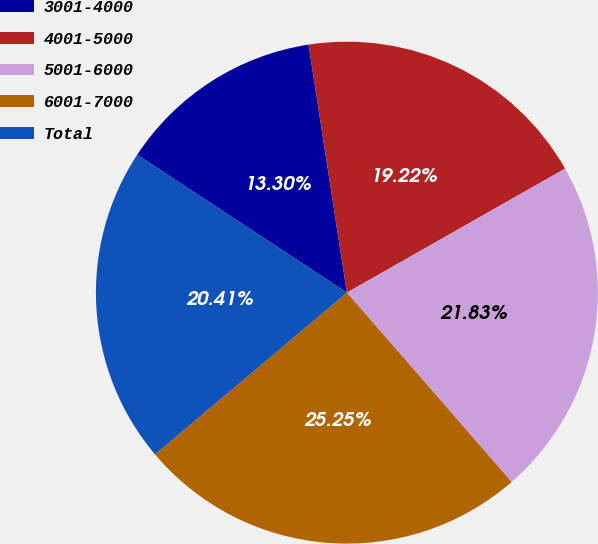Convert chart to OTSL. <chart><loc_0><loc_0><loc_500><loc_500><pie_chart><fcel>3001-4000<fcel>4001-5000<fcel>5001-6000<fcel>6001-7000<fcel>Total<nl><fcel>13.3%<fcel>19.22%<fcel>21.83%<fcel>25.25%<fcel>20.41%<nl></chart> 